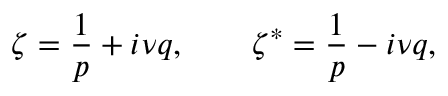Convert formula to latex. <formula><loc_0><loc_0><loc_500><loc_500>\zeta = \frac { 1 } { p } + i \nu q , \zeta ^ { * } = \frac { 1 } { p } - i \nu q ,</formula> 